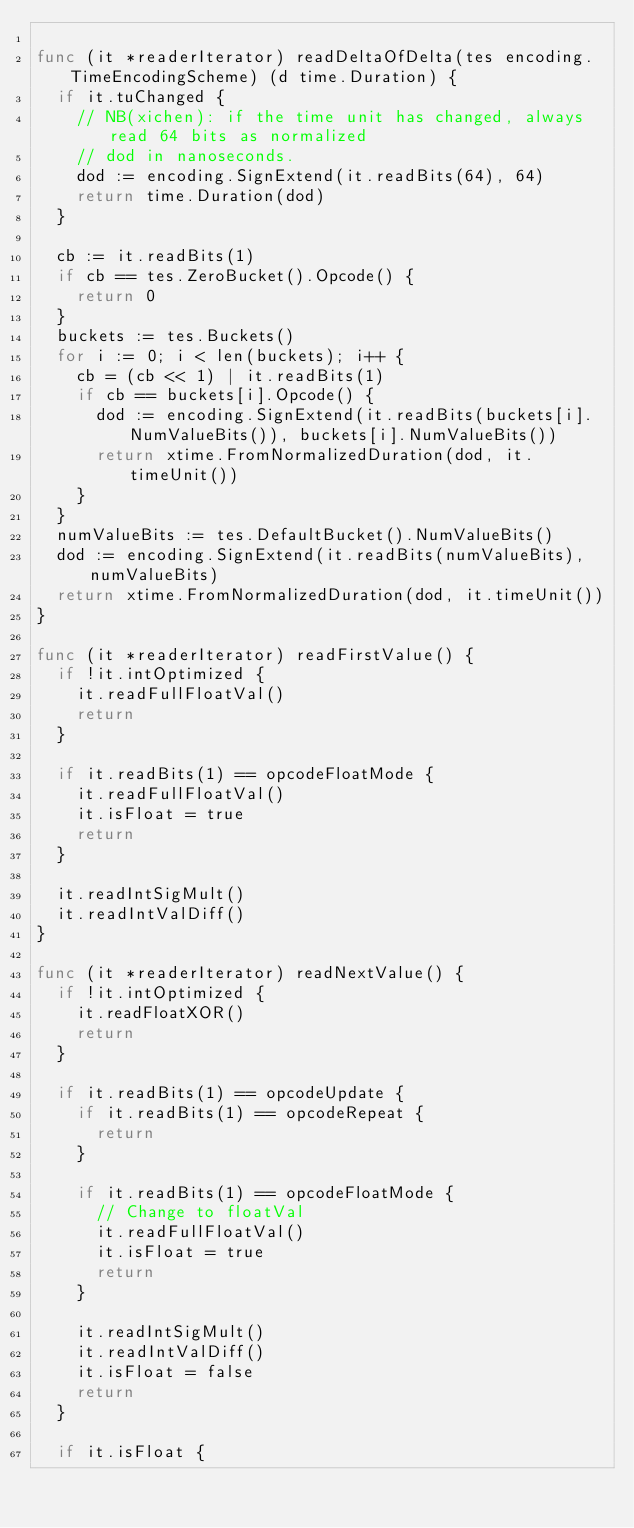<code> <loc_0><loc_0><loc_500><loc_500><_Go_>
func (it *readerIterator) readDeltaOfDelta(tes encoding.TimeEncodingScheme) (d time.Duration) {
	if it.tuChanged {
		// NB(xichen): if the time unit has changed, always read 64 bits as normalized
		// dod in nanoseconds.
		dod := encoding.SignExtend(it.readBits(64), 64)
		return time.Duration(dod)
	}

	cb := it.readBits(1)
	if cb == tes.ZeroBucket().Opcode() {
		return 0
	}
	buckets := tes.Buckets()
	for i := 0; i < len(buckets); i++ {
		cb = (cb << 1) | it.readBits(1)
		if cb == buckets[i].Opcode() {
			dod := encoding.SignExtend(it.readBits(buckets[i].NumValueBits()), buckets[i].NumValueBits())
			return xtime.FromNormalizedDuration(dod, it.timeUnit())
		}
	}
	numValueBits := tes.DefaultBucket().NumValueBits()
	dod := encoding.SignExtend(it.readBits(numValueBits), numValueBits)
	return xtime.FromNormalizedDuration(dod, it.timeUnit())
}

func (it *readerIterator) readFirstValue() {
	if !it.intOptimized {
		it.readFullFloatVal()
		return
	}

	if it.readBits(1) == opcodeFloatMode {
		it.readFullFloatVal()
		it.isFloat = true
		return
	}

	it.readIntSigMult()
	it.readIntValDiff()
}

func (it *readerIterator) readNextValue() {
	if !it.intOptimized {
		it.readFloatXOR()
		return
	}

	if it.readBits(1) == opcodeUpdate {
		if it.readBits(1) == opcodeRepeat {
			return
		}

		if it.readBits(1) == opcodeFloatMode {
			// Change to floatVal
			it.readFullFloatVal()
			it.isFloat = true
			return
		}

		it.readIntSigMult()
		it.readIntValDiff()
		it.isFloat = false
		return
	}

	if it.isFloat {</code> 